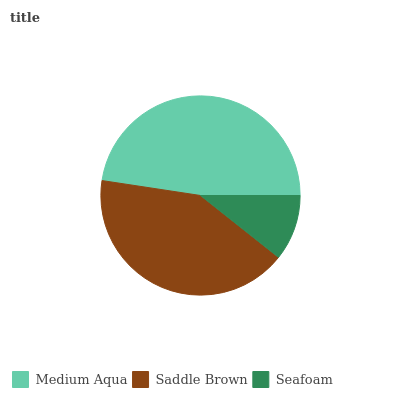Is Seafoam the minimum?
Answer yes or no. Yes. Is Medium Aqua the maximum?
Answer yes or no. Yes. Is Saddle Brown the minimum?
Answer yes or no. No. Is Saddle Brown the maximum?
Answer yes or no. No. Is Medium Aqua greater than Saddle Brown?
Answer yes or no. Yes. Is Saddle Brown less than Medium Aqua?
Answer yes or no. Yes. Is Saddle Brown greater than Medium Aqua?
Answer yes or no. No. Is Medium Aqua less than Saddle Brown?
Answer yes or no. No. Is Saddle Brown the high median?
Answer yes or no. Yes. Is Saddle Brown the low median?
Answer yes or no. Yes. Is Seafoam the high median?
Answer yes or no. No. Is Medium Aqua the low median?
Answer yes or no. No. 